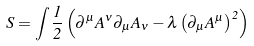<formula> <loc_0><loc_0><loc_500><loc_500>S = \int { \frac { 1 } { 2 } } \left ( \partial ^ { \mu } A ^ { \nu } \partial _ { \mu } A _ { \nu } - \lambda \left ( \partial _ { \mu } A ^ { \mu } \right ) ^ { 2 } \right )</formula> 